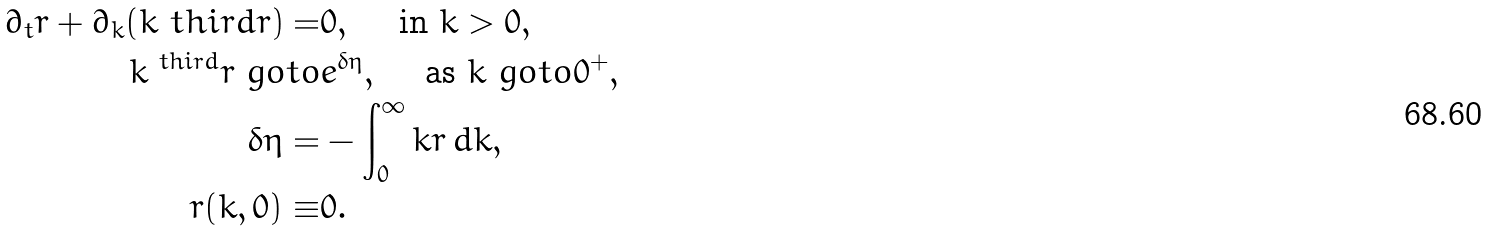<formula> <loc_0><loc_0><loc_500><loc_500>\partial _ { t } r + \partial _ { k } ( k ^ { \ } t h i r d r ) = & 0 , \quad \text { in } k > 0 , \\ k ^ { \ t h i r d } r \ g o t o & e ^ { \delta \eta } , \quad \text { as } k \ g o t o 0 ^ { + } , \\ \delta \eta = & - \int _ { 0 } ^ { \infty } k r \, d k , \\ r ( k , 0 ) \equiv & 0 .</formula> 